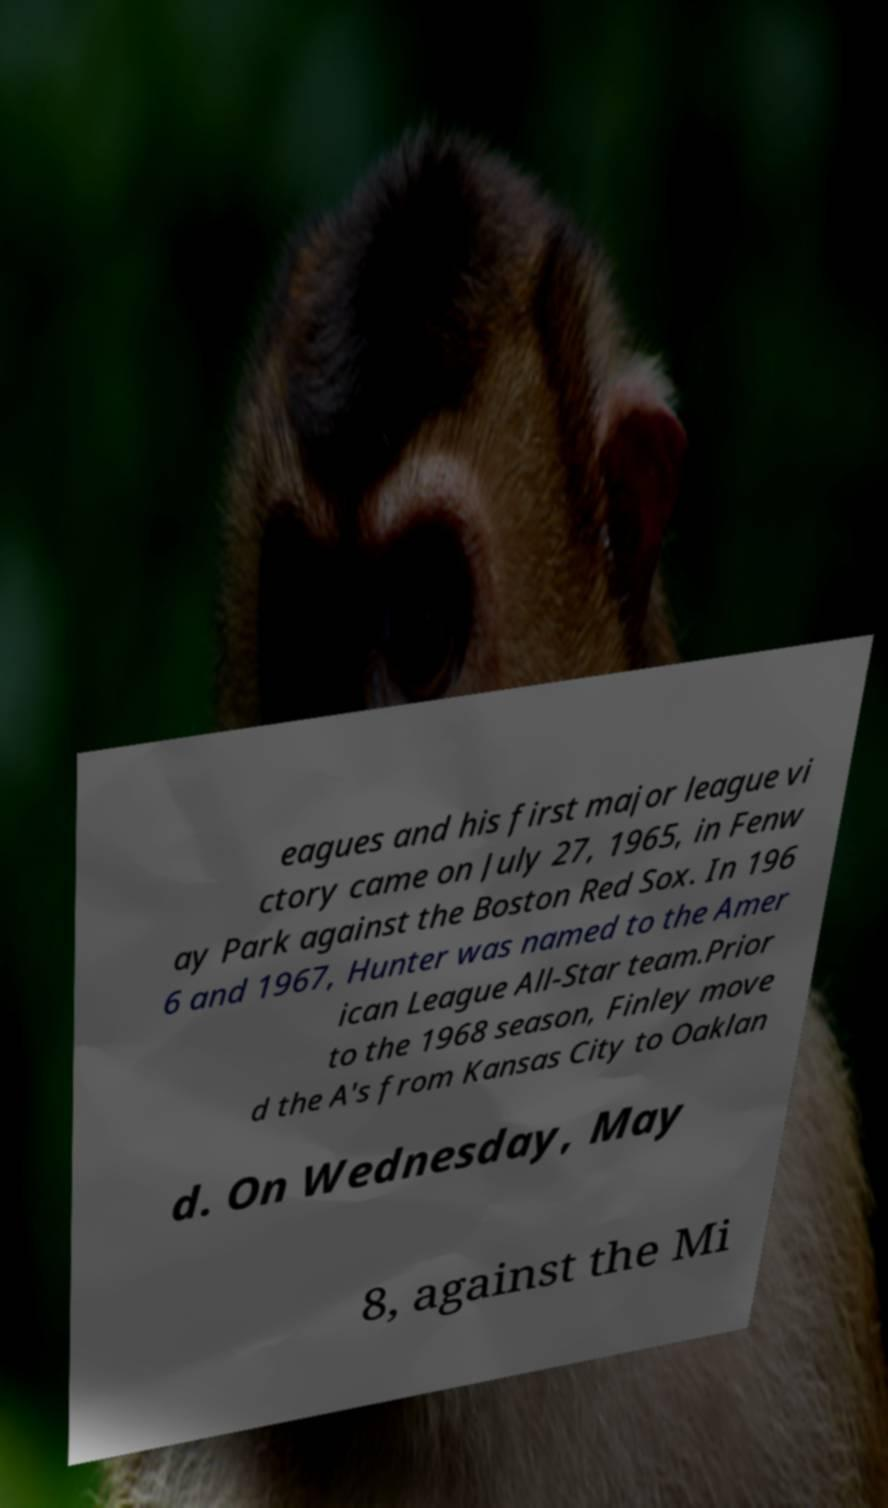Can you read and provide the text displayed in the image?This photo seems to have some interesting text. Can you extract and type it out for me? eagues and his first major league vi ctory came on July 27, 1965, in Fenw ay Park against the Boston Red Sox. In 196 6 and 1967, Hunter was named to the Amer ican League All-Star team.Prior to the 1968 season, Finley move d the A's from Kansas City to Oaklan d. On Wednesday, May 8, against the Mi 